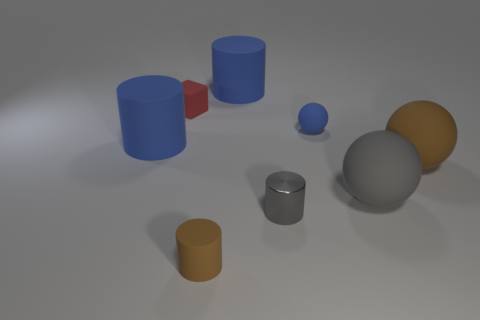Is the number of brown objects that are right of the tiny gray metal cylinder less than the number of blue things that are on the right side of the big gray thing?
Make the answer very short. No. There is a small sphere that is made of the same material as the tiny brown thing; what color is it?
Offer a very short reply. Blue. Are there any blue spheres left of the blue matte thing on the left side of the brown matte cylinder?
Provide a short and direct response. No. What color is the other sphere that is the same size as the gray rubber sphere?
Give a very brief answer. Brown. What number of things are either yellow shiny cubes or big gray rubber spheres?
Offer a very short reply. 1. How big is the blue matte thing on the left side of the brown object in front of the large brown rubber sphere that is behind the brown rubber cylinder?
Provide a short and direct response. Large. What number of big objects have the same color as the small shiny thing?
Provide a succinct answer. 1. How many blue cylinders have the same material as the red thing?
Offer a very short reply. 2. How many objects are small gray cylinders or big cylinders in front of the blue ball?
Offer a very short reply. 2. There is a large rubber object that is to the left of the rubber cylinder behind the blue matte ball that is to the left of the large gray matte thing; what color is it?
Provide a succinct answer. Blue. 